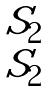Convert formula to latex. <formula><loc_0><loc_0><loc_500><loc_500>\begin{matrix} S _ { 2 } \\ S _ { 2 } \end{matrix}</formula> 